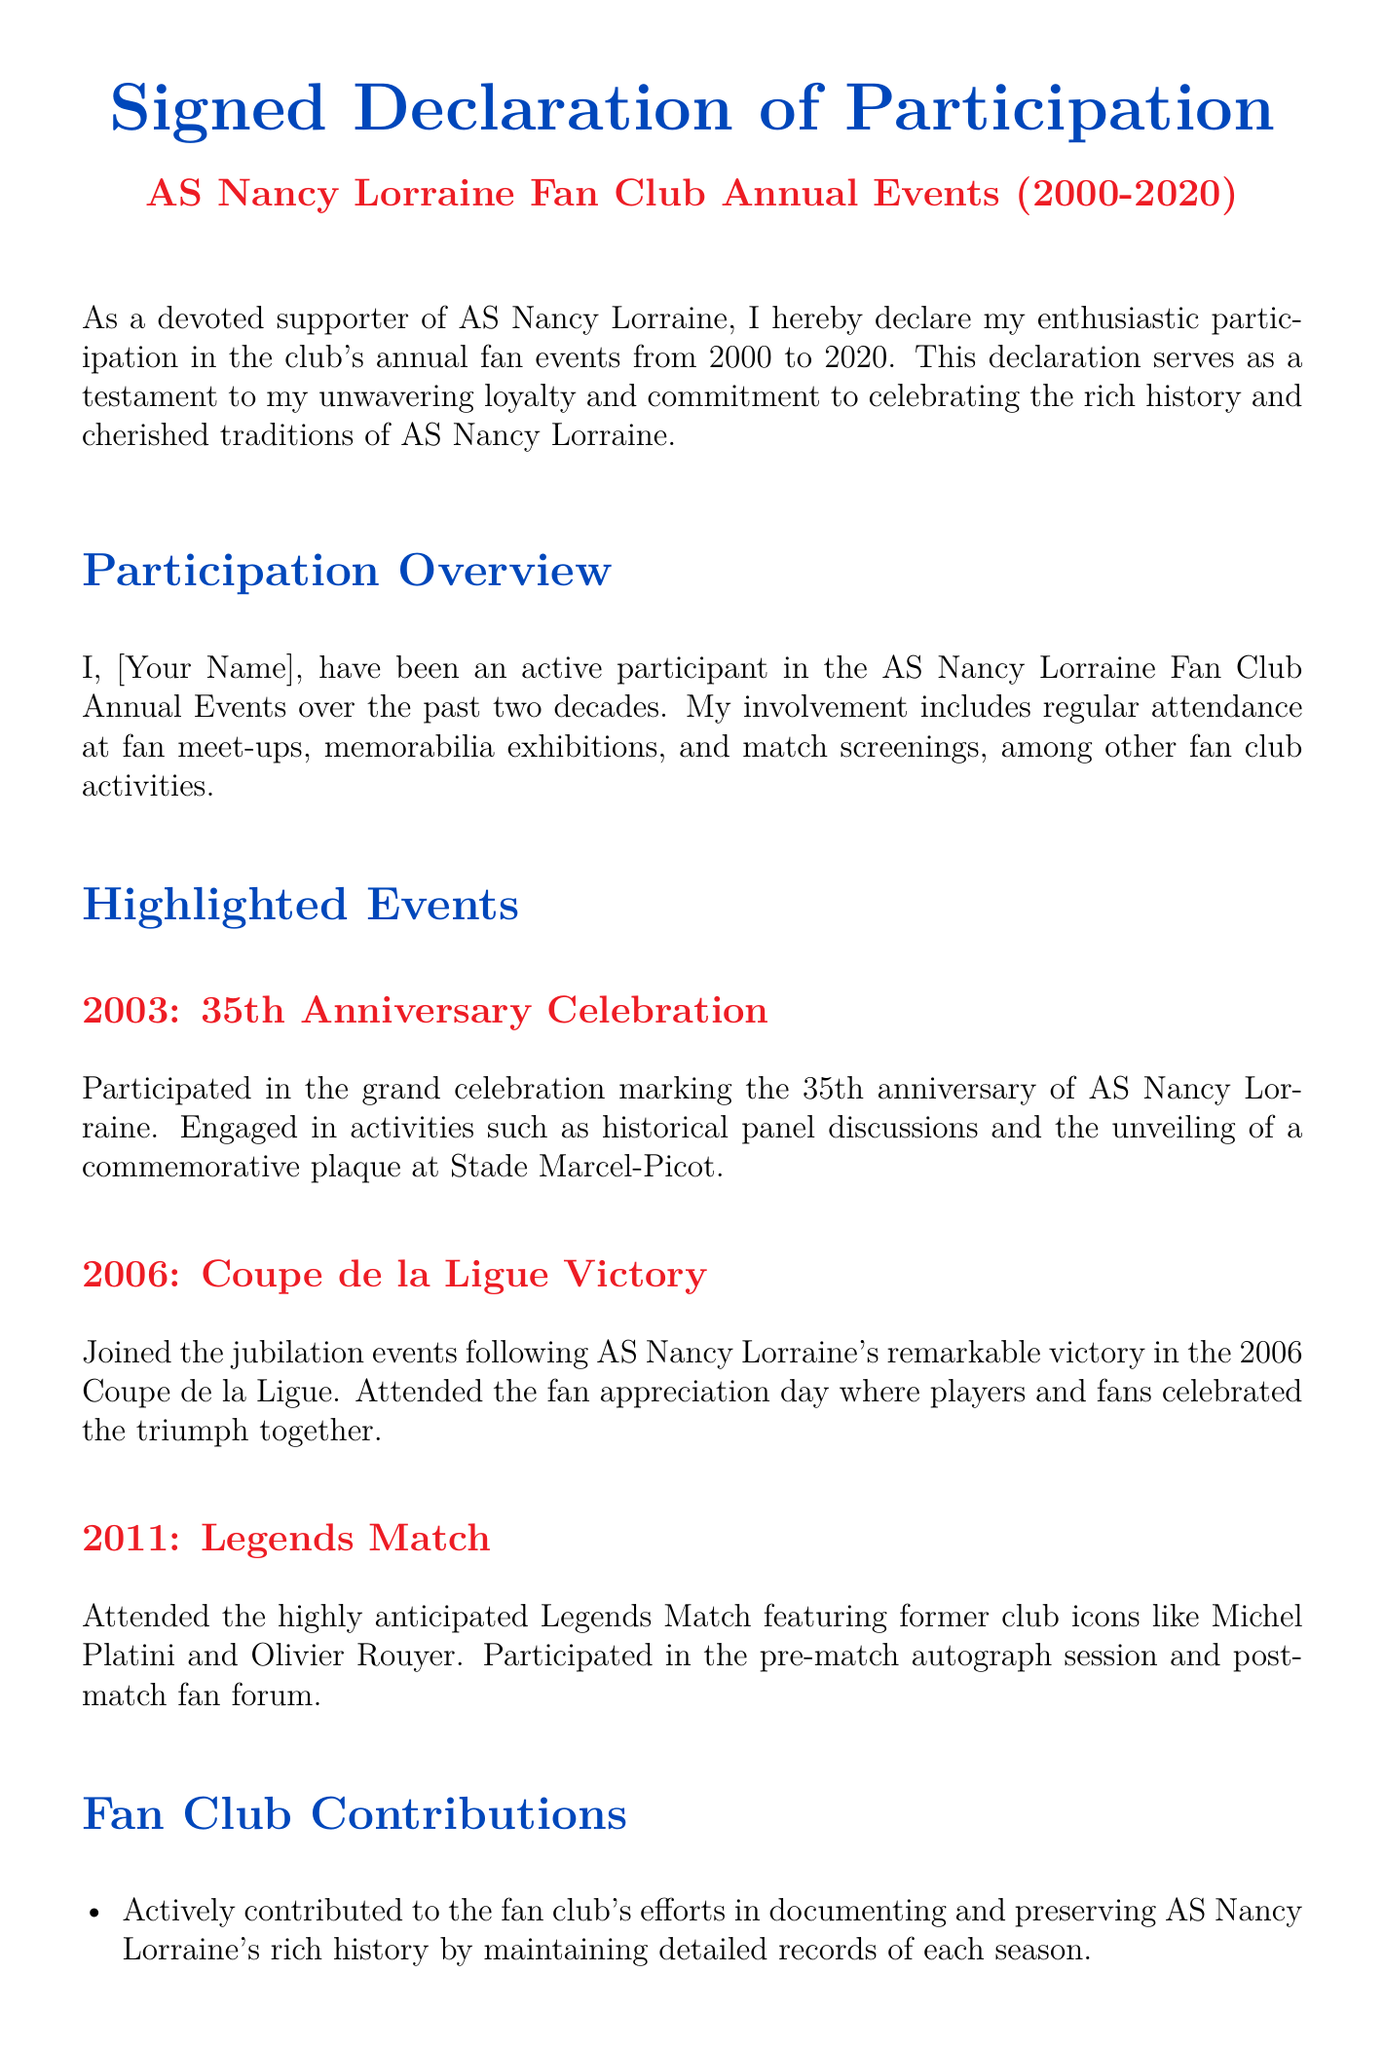What is the title of the document? The title is prominently displayed at the top of the document and summarizes the purpose clearly.
Answer: Signed Declaration of Participation In which year was the 35th Anniversary Celebration? The specific year of the celebrated anniversary is mentioned in the highlighted events section of the document.
Answer: 2003 What event does the document highlight from 2006? The highlighted event is referenced in the section detailing past fan events, indicating a significant moment in the club's recent history.
Answer: Coupe de la Ligue Victory Which two former club icons were mentioned in the Legends Match? The document provides the names of notable players who took part in this specific event from the club's history.
Answer: Michel Platini and Olivier Rouyer What type of contribution is mentioned regarding the fan club's history? The contributions relate to preserving and documenting the club's legacy and activities over the years as noted in the contributions section.
Answer: Detailed records of each season What color is primarily used for the section headers? The color used for section headers is specified with a defined color format at the beginning of the document.
Answer: Nancy blue On what date should the declaration be signed? The document includes a placeholder indicating where the signatory will input their signing date, demonstrating a formal requirement for such documents.
Answer: [Date] What type of activities did the participant engage in? The document outlines various forms of involvement in club activities, emphasizing the participant's commitment and engagement over the years.
Answer: Fan meet-ups, memorabilia exhibitions, match screenings 